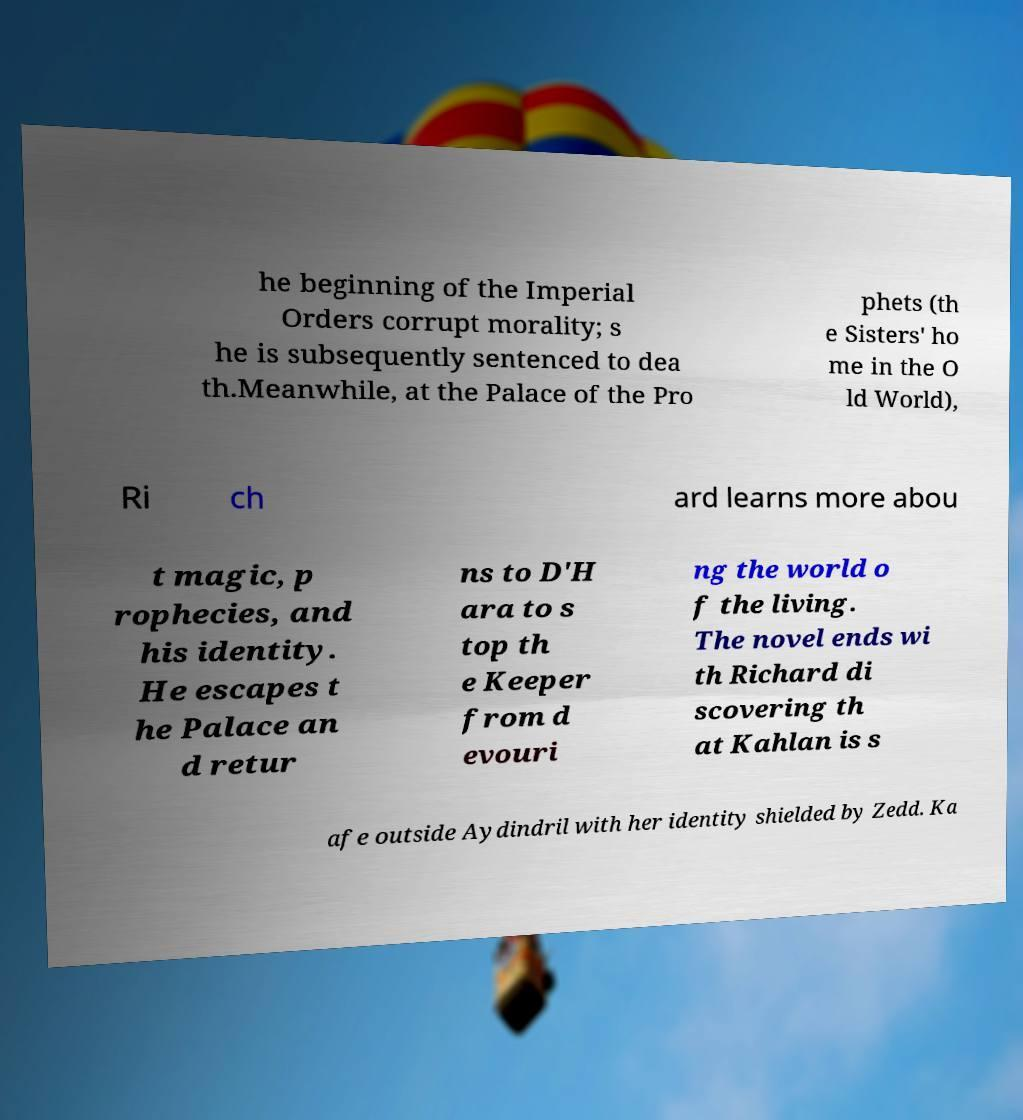Can you accurately transcribe the text from the provided image for me? he beginning of the Imperial Orders corrupt morality; s he is subsequently sentenced to dea th.Meanwhile, at the Palace of the Pro phets (th e Sisters' ho me in the O ld World), Ri ch ard learns more abou t magic, p rophecies, and his identity. He escapes t he Palace an d retur ns to D'H ara to s top th e Keeper from d evouri ng the world o f the living. The novel ends wi th Richard di scovering th at Kahlan is s afe outside Aydindril with her identity shielded by Zedd. Ka 